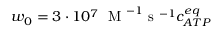Convert formula to latex. <formula><loc_0><loc_0><loc_500><loc_500>w _ { 0 } = 3 \cdot 1 0 ^ { 7 } \, M ^ { - 1 } s ^ { - 1 } c _ { A T P } ^ { e q }</formula> 